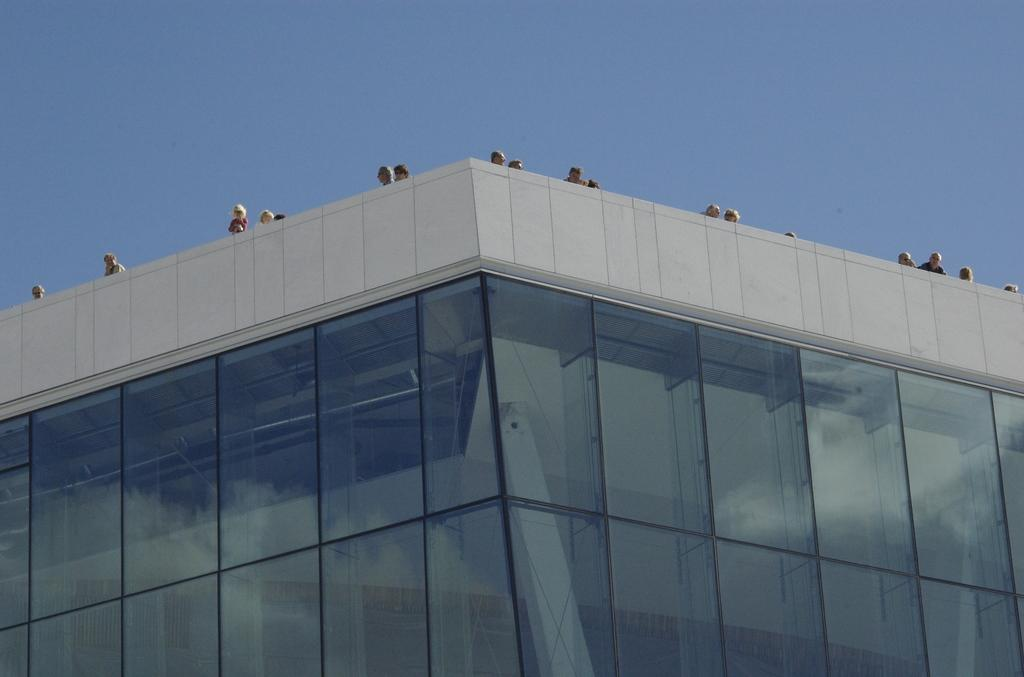What structure can be seen in the image? There is a building in the image. Where are the people in the image located? The people in the image are standing above the building. What can be seen in the background of the image? The sky is visible in the image. What type of paste is being used by the people standing above the building in the image? There is no paste visible in the image, and the people standing above the building are not using any paste. 